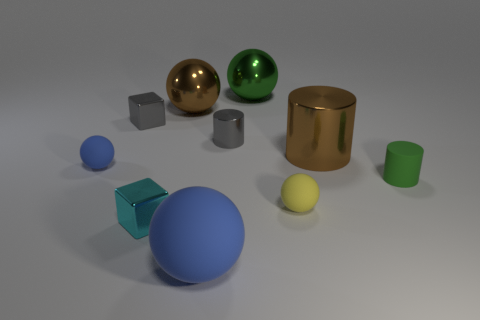How do the objects in the image appear to be arranged? The objects seem to be arranged randomly across the surface with varying distances between them, suggesting no specific pattern but creating a visually balanced composition. 